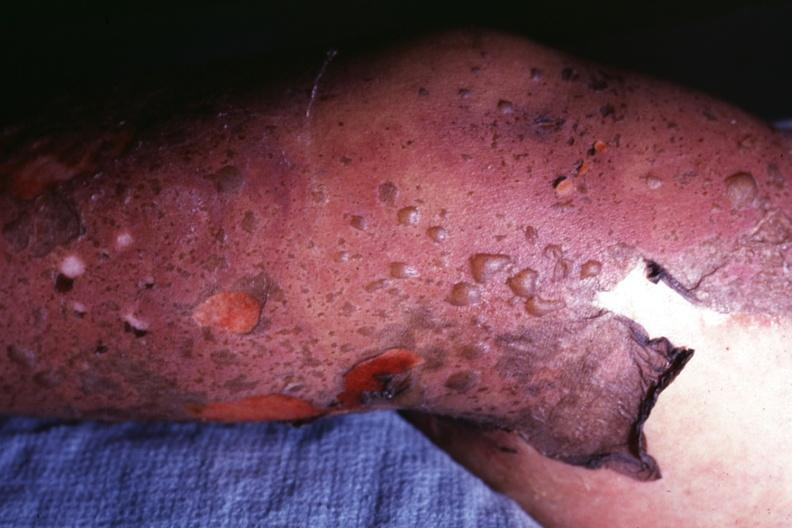how is this diagnosis as i do not have protocol?
Answer the question using a single word or phrase. Correct 